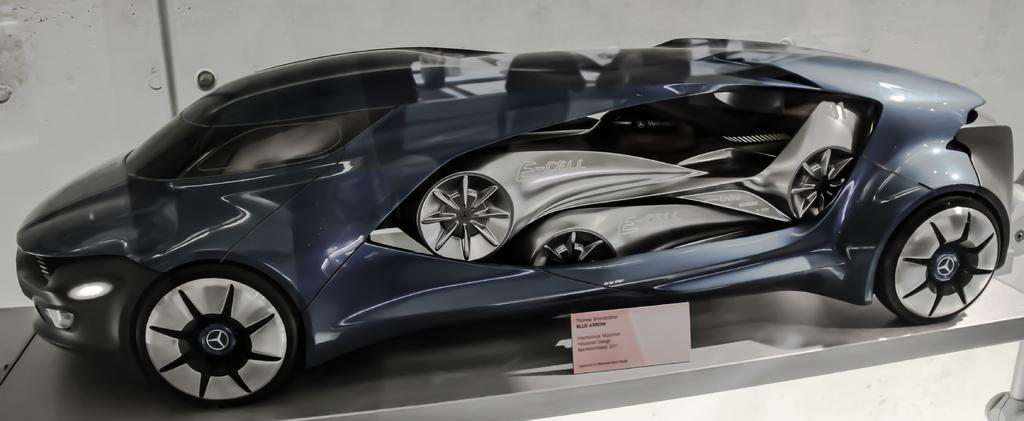What type of toy is present in the image? There is a toy car in the image. What else can be seen in the image besides the toy car? There is a small board with text in the image. What is visible in the background of the image? There is a wall in the background of the image. How many books are stacked on the toy car in the image? There are no books present in the image; it only features a toy car and a small board with text. 